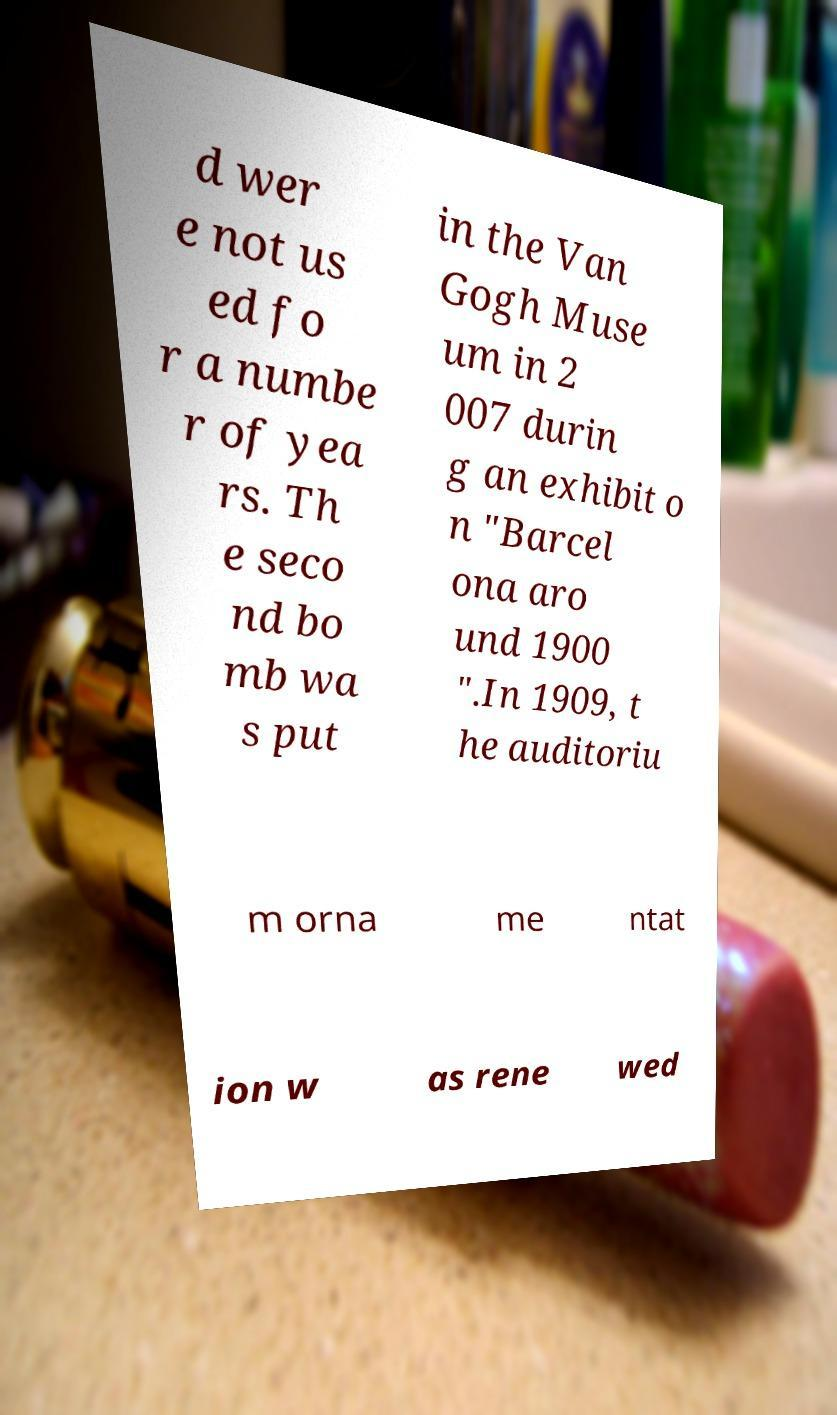What messages or text are displayed in this image? I need them in a readable, typed format. d wer e not us ed fo r a numbe r of yea rs. Th e seco nd bo mb wa s put in the Van Gogh Muse um in 2 007 durin g an exhibit o n "Barcel ona aro und 1900 ".In 1909, t he auditoriu m orna me ntat ion w as rene wed 